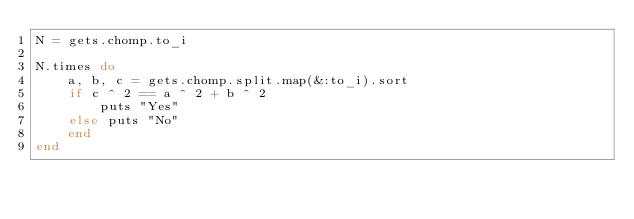Convert code to text. <code><loc_0><loc_0><loc_500><loc_500><_Ruby_>N = gets.chomp.to_i

N.times do
	a, b, c = gets.chomp.split.map(&:to_i).sort
	if c ^ 2 == a ^ 2 + b ^ 2
		puts "Yes"
	else puts "No"
	end
end</code> 